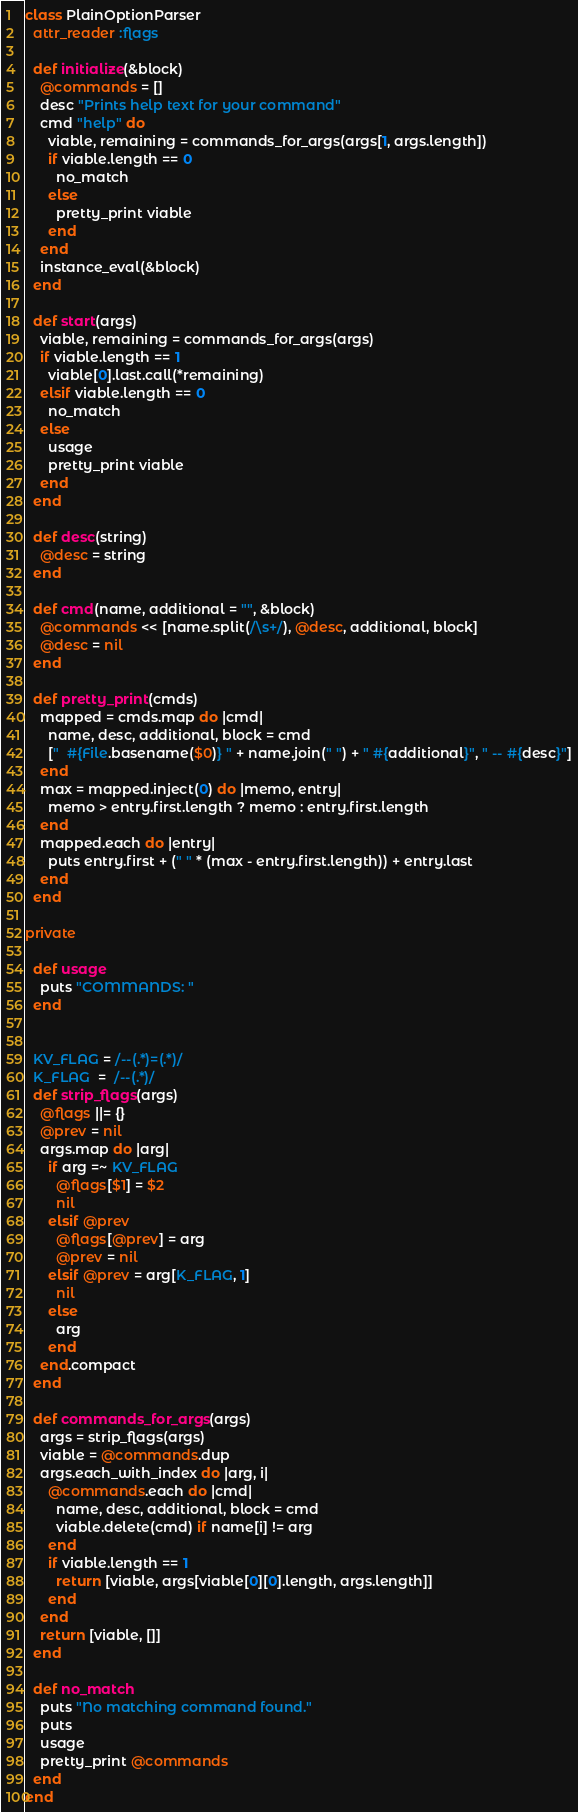Convert code to text. <code><loc_0><loc_0><loc_500><loc_500><_Ruby_>class PlainOptionParser
  attr_reader :flags
  
  def initialize(&block)
    @commands = []
    desc "Prints help text for your command"
    cmd "help" do
      viable, remaining = commands_for_args(args[1, args.length])
      if viable.length == 0
        no_match
      else
        pretty_print viable
      end
    end
    instance_eval(&block)
  end

  def start(args)
    viable, remaining = commands_for_args(args)
    if viable.length == 1
      viable[0].last.call(*remaining)
    elsif viable.length == 0
      no_match
    else
      usage
      pretty_print viable
    end
  end
  
  def desc(string)
    @desc = string
  end
    
  def cmd(name, additional = "", &block)
    @commands << [name.split(/\s+/), @desc, additional, block]
    @desc = nil
  end
  
  def pretty_print(cmds)
    mapped = cmds.map do |cmd|
      name, desc, additional, block = cmd
      ["  #{File.basename($0)} " + name.join(" ") + " #{additional}", " -- #{desc}"]
    end
    max = mapped.inject(0) do |memo, entry|
      memo > entry.first.length ? memo : entry.first.length
    end
    mapped.each do |entry|
      puts entry.first + (" " * (max - entry.first.length)) + entry.last
    end
  end
  
private
  
  def usage
    puts "COMMANDS: "
  end
  
  
  KV_FLAG = /--(.*)=(.*)/
  K_FLAG  =  /--(.*)/
  def strip_flags(args)
    @flags ||= {}
    @prev = nil
    args.map do |arg|
      if arg =~ KV_FLAG
        @flags[$1] = $2
        nil
      elsif @prev            
        @flags[@prev] = arg
        @prev = nil
      elsif @prev = arg[K_FLAG, 1]
        nil
      else
        arg
      end
    end.compact
  end
  
  def commands_for_args(args)
    args = strip_flags(args)
    viable = @commands.dup
    args.each_with_index do |arg, i|
      @commands.each do |cmd|
        name, desc, additional, block = cmd
        viable.delete(cmd) if name[i] != arg
      end
      if viable.length == 1
        return [viable, args[viable[0][0].length, args.length]]
      end
    end
    return [viable, []]
  end
  
  def no_match
    puts "No matching command found."
    puts 
    usage
    pretty_print @commands
  end
end</code> 